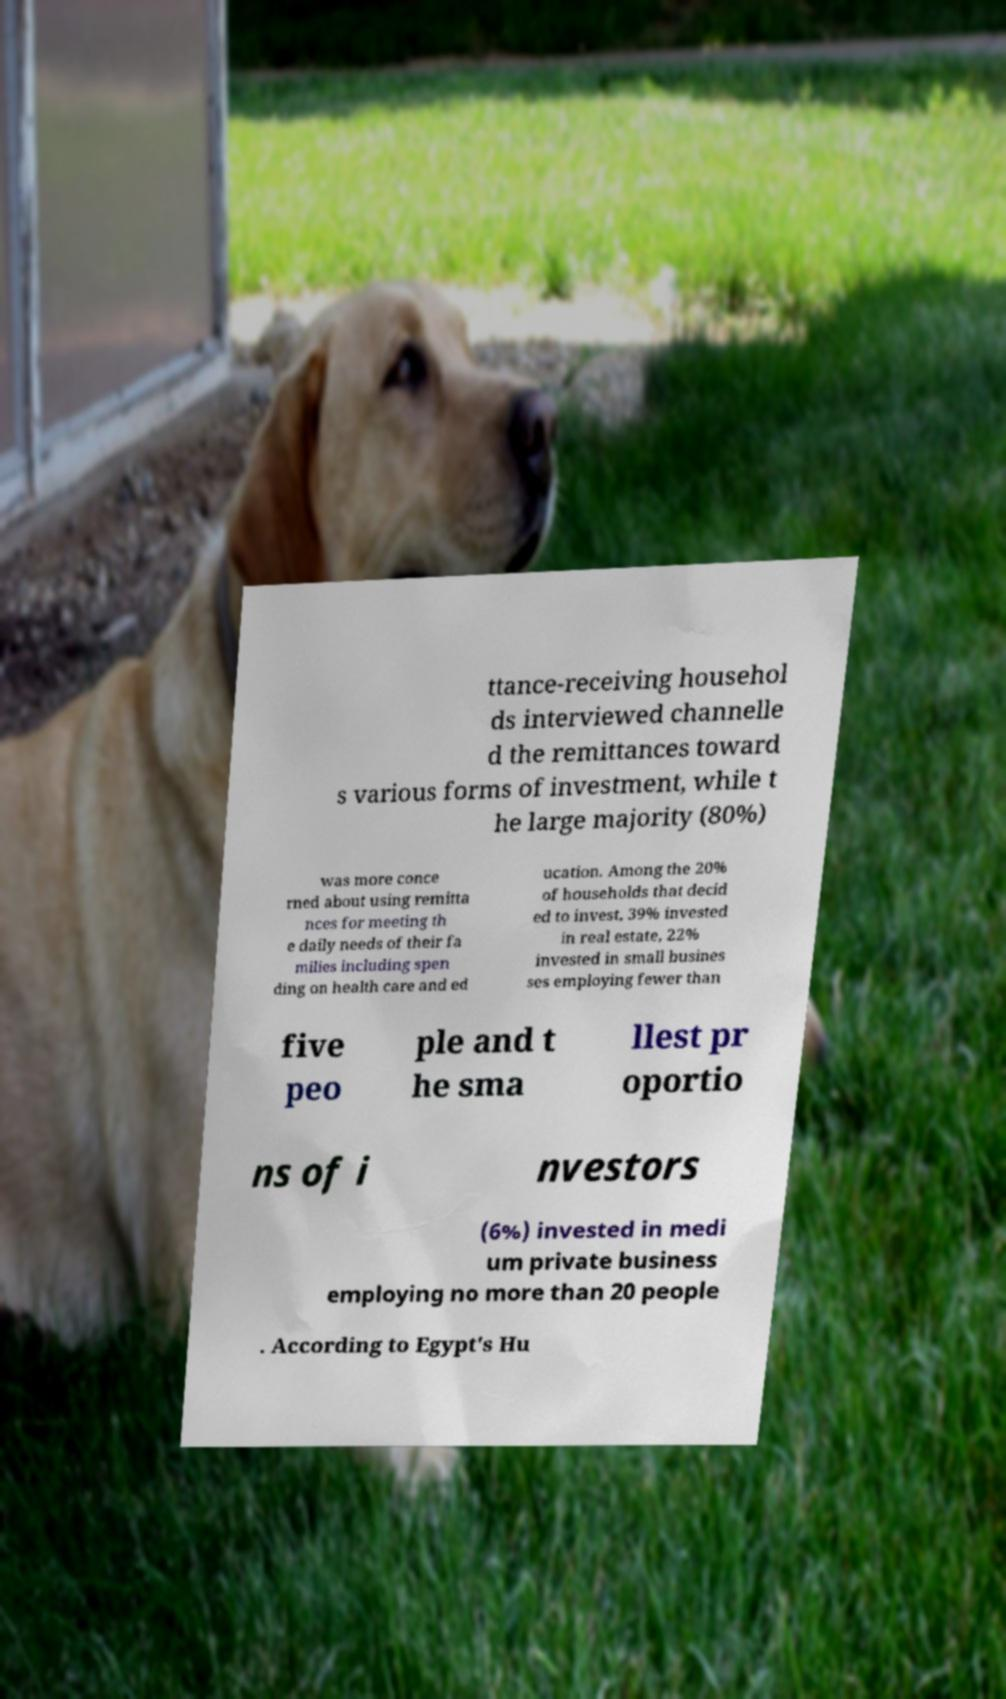What messages or text are displayed in this image? I need them in a readable, typed format. ttance-receiving househol ds interviewed channelle d the remittances toward s various forms of investment, while t he large majority (80%) was more conce rned about using remitta nces for meeting th e daily needs of their fa milies including spen ding on health care and ed ucation. Among the 20% of households that decid ed to invest, 39% invested in real estate, 22% invested in small busines ses employing fewer than five peo ple and t he sma llest pr oportio ns of i nvestors (6%) invested in medi um private business employing no more than 20 people . According to Egypt's Hu 